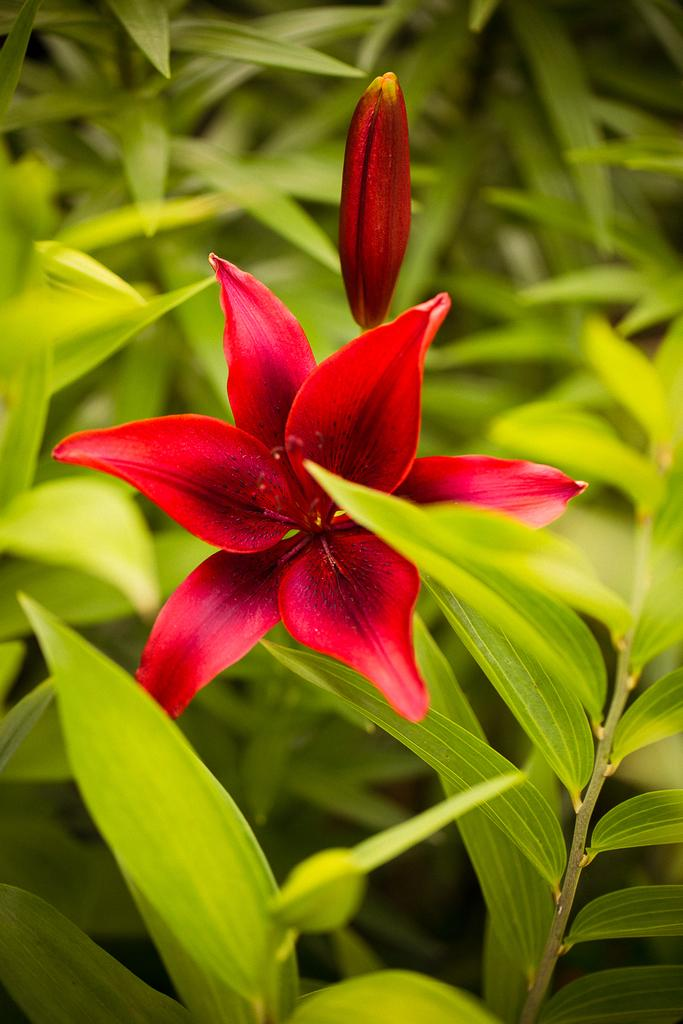What is the main subject in the foreground of the image? There is a red color flower in the foreground of the image. What is the relationship between the flower and the plant? The flower is part of a plant. What can be seen in the background of the image? The background of the image is covered with plants. How many sisters are visible in the image? There are no sisters present in the image; it features a red color flower in the foreground and plants in the background. 